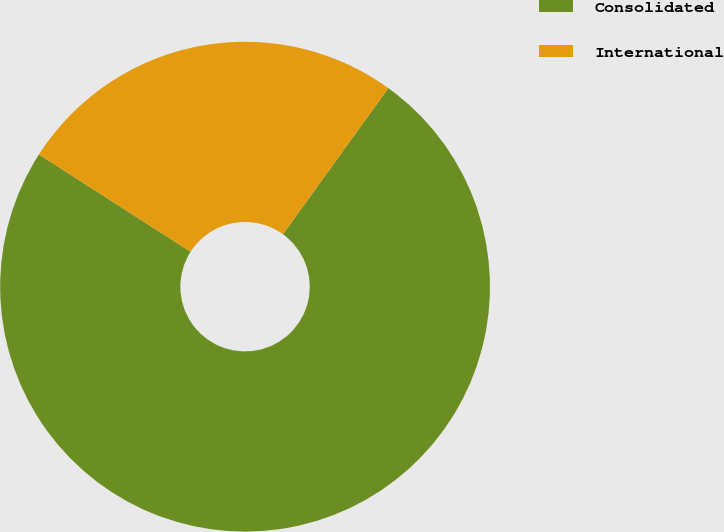<chart> <loc_0><loc_0><loc_500><loc_500><pie_chart><fcel>Consolidated<fcel>International<nl><fcel>74.13%<fcel>25.87%<nl></chart> 